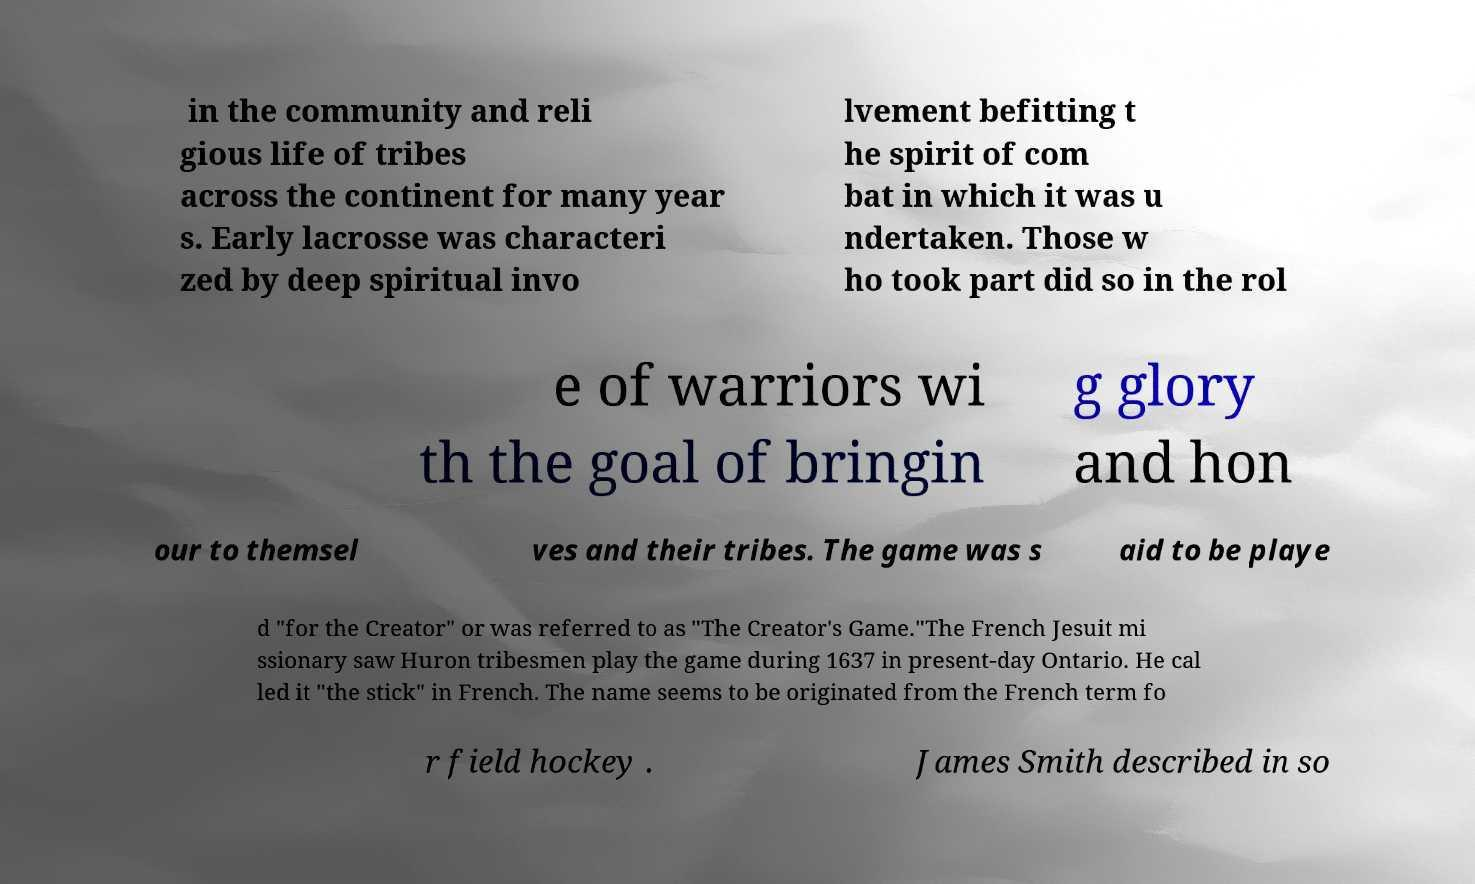Please read and relay the text visible in this image. What does it say? in the community and reli gious life of tribes across the continent for many year s. Early lacrosse was characteri zed by deep spiritual invo lvement befitting t he spirit of com bat in which it was u ndertaken. Those w ho took part did so in the rol e of warriors wi th the goal of bringin g glory and hon our to themsel ves and their tribes. The game was s aid to be playe d "for the Creator" or was referred to as "The Creator's Game."The French Jesuit mi ssionary saw Huron tribesmen play the game during 1637 in present-day Ontario. He cal led it "the stick" in French. The name seems to be originated from the French term fo r field hockey . James Smith described in so 